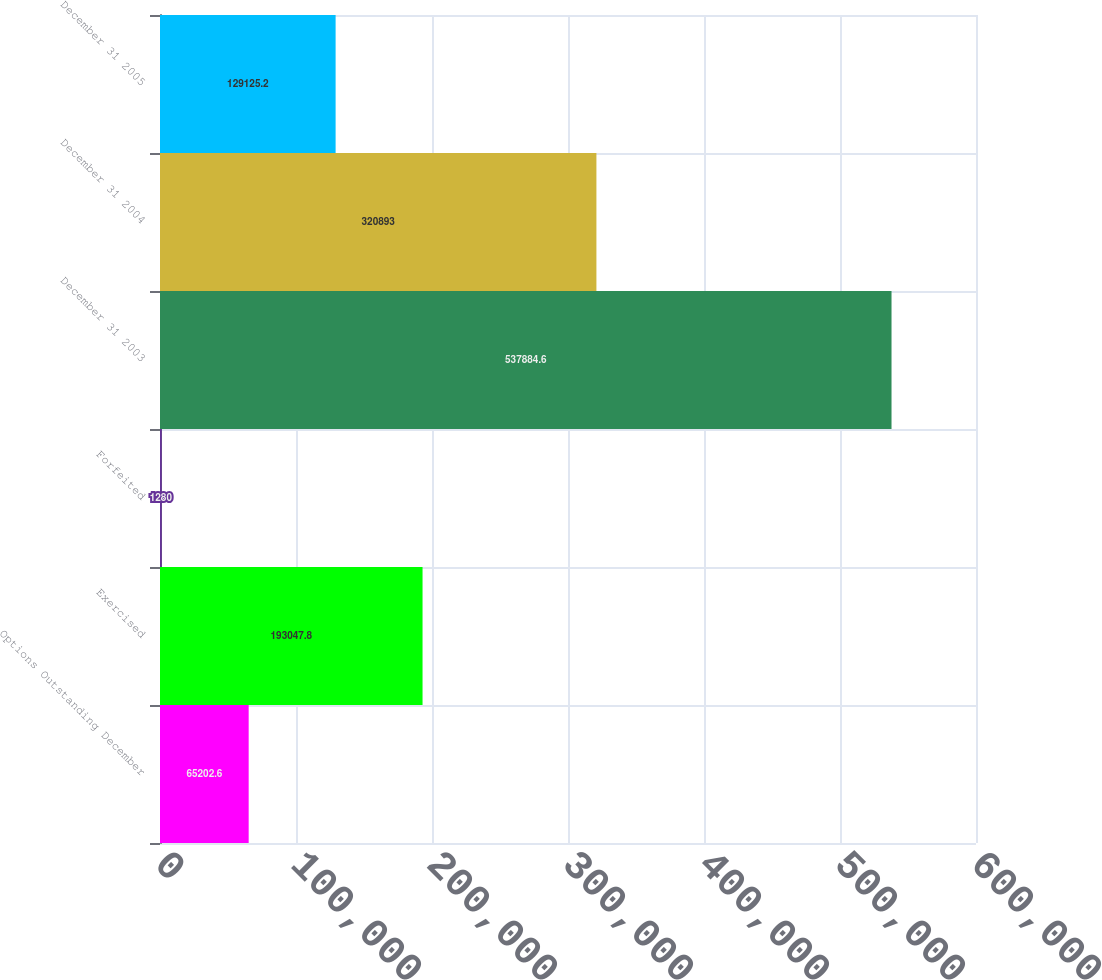Convert chart. <chart><loc_0><loc_0><loc_500><loc_500><bar_chart><fcel>Options Outstanding December<fcel>Exercised<fcel>Forfeited<fcel>December 31 2003<fcel>December 31 2004<fcel>December 31 2005<nl><fcel>65202.6<fcel>193048<fcel>1280<fcel>537885<fcel>320893<fcel>129125<nl></chart> 